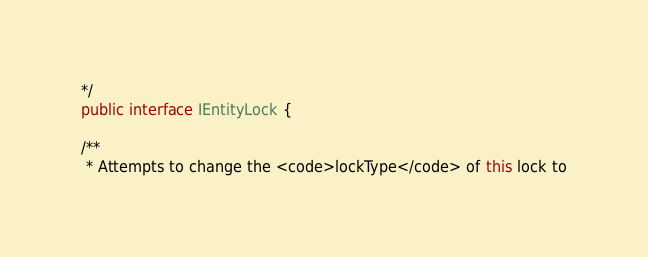Convert code to text. <code><loc_0><loc_0><loc_500><loc_500><_Java_>*/
public interface IEntityLock {

/**
 * Attempts to change the <code>lockType</code> of this lock to</code> 